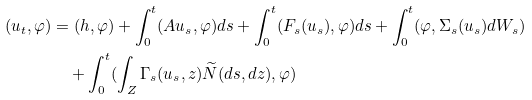<formula> <loc_0><loc_0><loc_500><loc_500>( u _ { t } , \varphi ) & = ( h , \varphi ) + \int _ { 0 } ^ { t } ( A u _ { s } , \varphi ) d s + \int _ { 0 } ^ { t } ( F _ { s } ( u _ { s } ) , \varphi ) d s + \int _ { 0 } ^ { t } ( \varphi , \Sigma _ { s } ( u _ { s } ) d W _ { s } ) \\ & \quad + \int _ { 0 } ^ { t } ( \int _ { Z } \Gamma _ { s } ( u _ { s } , z ) \widetilde { N } ( d s , d z ) , \varphi )</formula> 